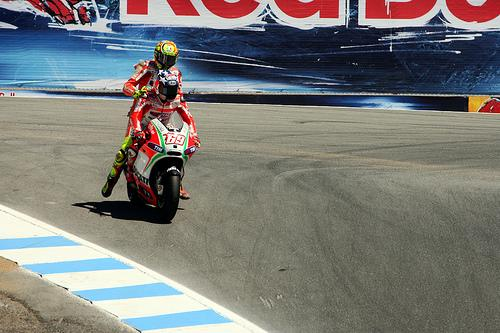Can you identify any possible source of information present in the picture that could provide context to the race? There is a sign for Red Bull in the background, suggesting that the race could be sponsored by or affiliated with the brand. What additional safety gear do the motorcyclists wear other than their helmets? The motorcyclists wear protective knee pads and racing suits. Describe the scene and time of day in which the motorcycle racing is happening. The scene is an outdoor race track during the day, with signage on the wall and a Red Bull logo in the background. Identify the main activity taking place in the picture and mention the key elements involved. Motorcycle racing is happening in the image, with two people wearing helmets and racing gear riding a red, white, and green motorcycle on a grey racetrack. Explain what type of company's advertisement may be in the background of the picture. A Red Bull advertisement, as it features a Red Bull logo. How would you describe the wheel on the front of the motorcycle? The front wheel of the motorcycle is black with tire marks, and possibly a very smooth track tire. What number is visible on the motorcycle, and where is it located? The number 69 is visible on the motorcycle, located on its side. Can you identify the color and pattern of the track boundary? The track boundary has blue and white stripes. List the colors and details of the helmets worn by both the driver and the passenger on the motorcycle. The driver has a yellow and red helmet, while the passenger has a multicolored helmet featuring yellow. Give a brief description of the pavement and the possible tracks or marks left on it. The pavement is grey and has tire tracks, skid marks, and guiding lines painted on it. What type of racing is depicted in the image? motorcycle racing What do you think about the unique graffiti art on the race track wall just behind the motorcycle? This instruction is misleading because it introduces a false object (graffiti art on the race track wall) and uses an interrogative sentence to entice the reader to look for the non-existent art and form an opinion about it. What are the motorcyclists wearing to protect their heads? motorcycle helmets Describe the colors of the racing bike's number. red lettering What can you tell me about the texture of the road? It is made of asphalt and appears very smooth. Notice how the wind seems to blow the autumn leaves across the grey pavement on this sunny day. This statement is deceptive because it introduces a false object (autumn leaves) along with a false setting (windy and sunny) using a declarative sentence. This makes the reader believe there are multiple false elements in the image. What type of markings are on the ground? guiding lines painted on the street and skid marks Is there any anomaly detection in the image? No Describe the road where the motorcycle is. grey pavement with tire tracks The race track's unique landscape features a majestic waterfall cascading just beyond the blue and white stripes. The statement deceptively introduces a false object (a waterfall) along with the location (beyond the blue and white stripes), using a declarative sentence. This will lead the reader to believe the imaginary waterfall exists in the background landscape of the racing track image. What type of footwear is visible in the image? racing boots What color are the helmets worn by the motorcyclists? yellow and red, and white with stars Can you imagine the sound of the roaring crowd cheering in the stands as the two motorcyclists race past? This misleading question introduces a non-existent object (roaring crowd in the stands) and asks the reader to imagine the sound of it, making them believe there is a crowd surrounding the race track. What color are the side lines of the track? blue and white Which object in the image has dimensions X:92 Y:97 Width:132 Height:132? motorcycle with 69 on it Which object in the image has a width of 462 and height of 462? Red Bull sign Can you spot the white seagull flying above the racing track? The instruction is misleading because it introduces a non-existent object (white seagull) and poses an interrogative question aiming at making the reader search for something that is not there. Are the people on the motorcycle wearing matching gear? Yes, they are both wearing racing gear. What is the number written on the motorcycle? 69 Estimate the size of the area with the grey pavement. X:268 Y:105 Width:180 Height:180 Indeed, there's a lively squirrel scurrying along the edge of the pavement. This deceptive statement introduces a false object (a squirrel) and provides a declarative sentence making the reader believe that it actually exists in the image. Is there any textual information present in the objects found in the photo? Yes, the number "69" on the motorcycle and the Red Bull sign. What safety equipment is shown on the passenger of the motorcycle? yellow multicolored helmet Which brand is represented by the sign in the image? Red Bull What type of setting is the picture taken in? outside and a motorcycle race track 